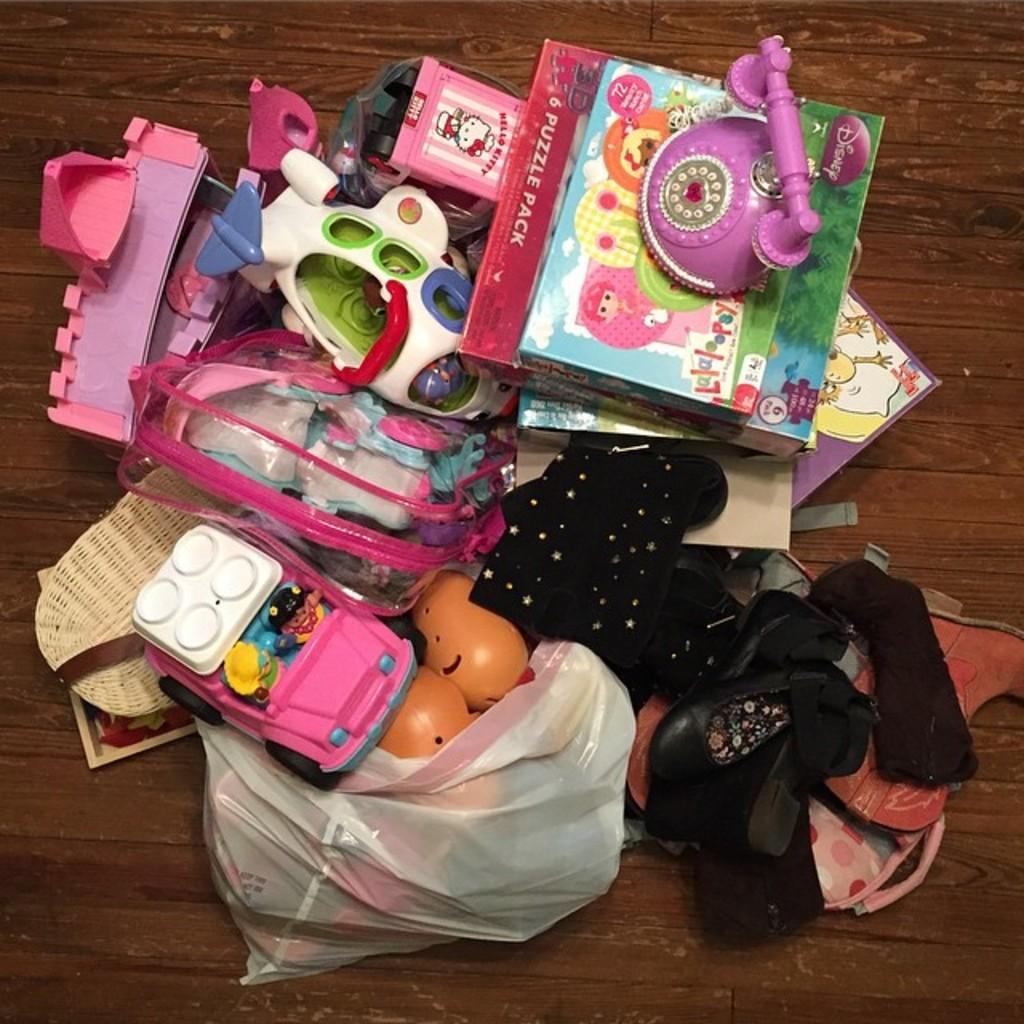What type of items can be seen on the table in the image? There are toys and forswears in the image. Are there any other objects on the table besides the toys and forswears? Yes, there are other objects on the table in the image. How many cats are sitting on the table in the image? There are no cats present in the image. Is there a birthday cake on the table in the image? There is no mention of a birthday cake or any celebration in the image. 